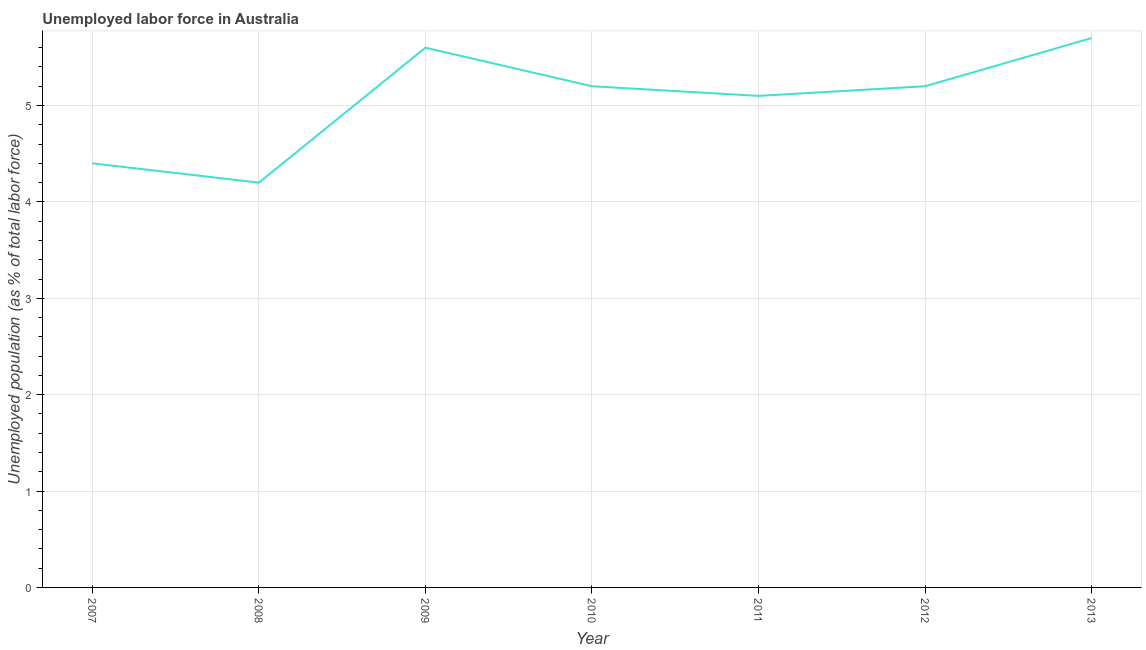What is the total unemployed population in 2012?
Ensure brevity in your answer.  5.2. Across all years, what is the maximum total unemployed population?
Make the answer very short. 5.7. Across all years, what is the minimum total unemployed population?
Your response must be concise. 4.2. What is the sum of the total unemployed population?
Ensure brevity in your answer.  35.4. What is the difference between the total unemployed population in 2008 and 2012?
Provide a succinct answer. -1. What is the average total unemployed population per year?
Keep it short and to the point. 5.06. What is the median total unemployed population?
Your answer should be compact. 5.2. In how many years, is the total unemployed population greater than 2.2 %?
Make the answer very short. 7. What is the ratio of the total unemployed population in 2007 to that in 2008?
Keep it short and to the point. 1.05. Is the difference between the total unemployed population in 2009 and 2013 greater than the difference between any two years?
Your answer should be compact. No. What is the difference between the highest and the second highest total unemployed population?
Ensure brevity in your answer.  0.1. Is the sum of the total unemployed population in 2011 and 2013 greater than the maximum total unemployed population across all years?
Your response must be concise. Yes. What is the difference between the highest and the lowest total unemployed population?
Provide a succinct answer. 1.5. Does the total unemployed population monotonically increase over the years?
Provide a succinct answer. No. How many lines are there?
Keep it short and to the point. 1. How many years are there in the graph?
Keep it short and to the point. 7. What is the difference between two consecutive major ticks on the Y-axis?
Your answer should be compact. 1. Are the values on the major ticks of Y-axis written in scientific E-notation?
Keep it short and to the point. No. Does the graph contain any zero values?
Ensure brevity in your answer.  No. Does the graph contain grids?
Offer a terse response. Yes. What is the title of the graph?
Offer a very short reply. Unemployed labor force in Australia. What is the label or title of the Y-axis?
Make the answer very short. Unemployed population (as % of total labor force). What is the Unemployed population (as % of total labor force) in 2007?
Provide a succinct answer. 4.4. What is the Unemployed population (as % of total labor force) of 2008?
Your answer should be compact. 4.2. What is the Unemployed population (as % of total labor force) of 2009?
Your answer should be very brief. 5.6. What is the Unemployed population (as % of total labor force) of 2010?
Keep it short and to the point. 5.2. What is the Unemployed population (as % of total labor force) in 2011?
Ensure brevity in your answer.  5.1. What is the Unemployed population (as % of total labor force) of 2012?
Your answer should be very brief. 5.2. What is the Unemployed population (as % of total labor force) of 2013?
Ensure brevity in your answer.  5.7. What is the difference between the Unemployed population (as % of total labor force) in 2007 and 2008?
Give a very brief answer. 0.2. What is the difference between the Unemployed population (as % of total labor force) in 2007 and 2009?
Ensure brevity in your answer.  -1.2. What is the difference between the Unemployed population (as % of total labor force) in 2007 and 2010?
Make the answer very short. -0.8. What is the difference between the Unemployed population (as % of total labor force) in 2007 and 2011?
Your answer should be compact. -0.7. What is the difference between the Unemployed population (as % of total labor force) in 2007 and 2013?
Provide a succinct answer. -1.3. What is the difference between the Unemployed population (as % of total labor force) in 2008 and 2012?
Ensure brevity in your answer.  -1. What is the difference between the Unemployed population (as % of total labor force) in 2009 and 2011?
Your response must be concise. 0.5. What is the difference between the Unemployed population (as % of total labor force) in 2009 and 2012?
Provide a succinct answer. 0.4. What is the difference between the Unemployed population (as % of total labor force) in 2010 and 2012?
Your response must be concise. 0. What is the difference between the Unemployed population (as % of total labor force) in 2010 and 2013?
Keep it short and to the point. -0.5. What is the difference between the Unemployed population (as % of total labor force) in 2011 and 2012?
Give a very brief answer. -0.1. What is the difference between the Unemployed population (as % of total labor force) in 2011 and 2013?
Offer a very short reply. -0.6. What is the ratio of the Unemployed population (as % of total labor force) in 2007 to that in 2008?
Offer a terse response. 1.05. What is the ratio of the Unemployed population (as % of total labor force) in 2007 to that in 2009?
Keep it short and to the point. 0.79. What is the ratio of the Unemployed population (as % of total labor force) in 2007 to that in 2010?
Keep it short and to the point. 0.85. What is the ratio of the Unemployed population (as % of total labor force) in 2007 to that in 2011?
Provide a short and direct response. 0.86. What is the ratio of the Unemployed population (as % of total labor force) in 2007 to that in 2012?
Ensure brevity in your answer.  0.85. What is the ratio of the Unemployed population (as % of total labor force) in 2007 to that in 2013?
Your response must be concise. 0.77. What is the ratio of the Unemployed population (as % of total labor force) in 2008 to that in 2010?
Offer a very short reply. 0.81. What is the ratio of the Unemployed population (as % of total labor force) in 2008 to that in 2011?
Give a very brief answer. 0.82. What is the ratio of the Unemployed population (as % of total labor force) in 2008 to that in 2012?
Ensure brevity in your answer.  0.81. What is the ratio of the Unemployed population (as % of total labor force) in 2008 to that in 2013?
Provide a short and direct response. 0.74. What is the ratio of the Unemployed population (as % of total labor force) in 2009 to that in 2010?
Make the answer very short. 1.08. What is the ratio of the Unemployed population (as % of total labor force) in 2009 to that in 2011?
Offer a terse response. 1.1. What is the ratio of the Unemployed population (as % of total labor force) in 2009 to that in 2012?
Provide a succinct answer. 1.08. What is the ratio of the Unemployed population (as % of total labor force) in 2010 to that in 2013?
Your response must be concise. 0.91. What is the ratio of the Unemployed population (as % of total labor force) in 2011 to that in 2012?
Provide a short and direct response. 0.98. What is the ratio of the Unemployed population (as % of total labor force) in 2011 to that in 2013?
Keep it short and to the point. 0.9. What is the ratio of the Unemployed population (as % of total labor force) in 2012 to that in 2013?
Ensure brevity in your answer.  0.91. 